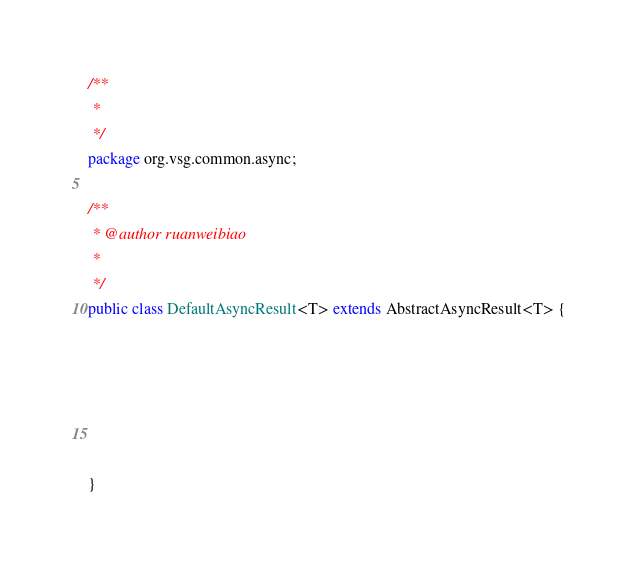<code> <loc_0><loc_0><loc_500><loc_500><_Java_>/**
 * 
 */
package org.vsg.common.async;

/**
 * @author ruanweibiao
 *
 */
public class DefaultAsyncResult<T> extends AbstractAsyncResult<T> {
	

	
	
	

}
</code> 